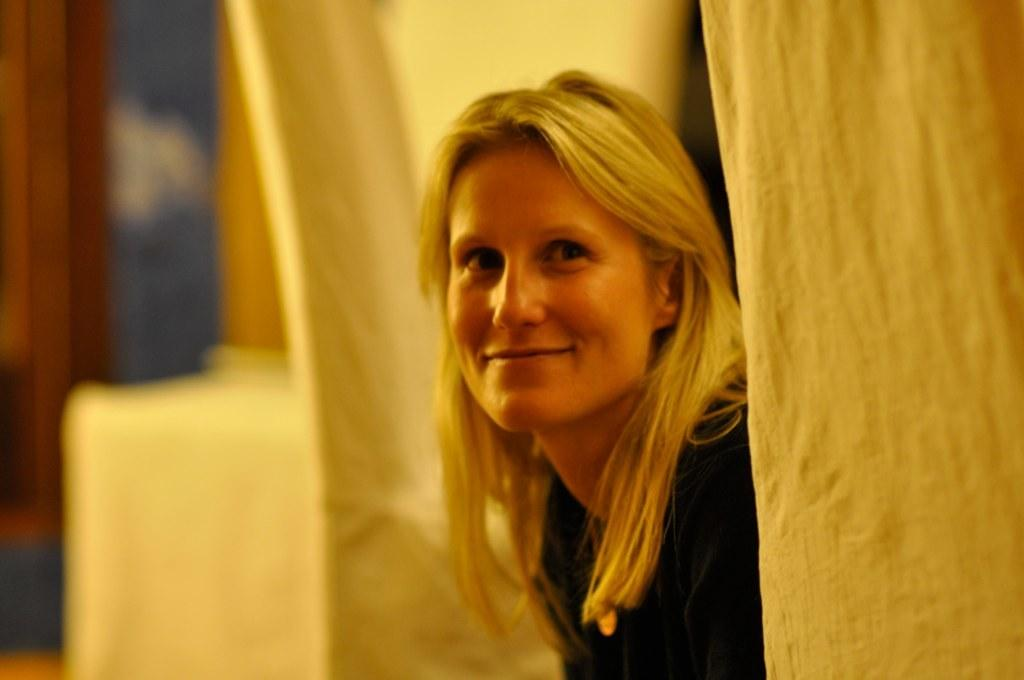Who is in the image? There is a person in the image. What is the person wearing? The person is wearing a black dress. What expression does the person have? The person is smiling. What can be seen next to the person? There is cloth visible next to the person. How would you describe the background of the image? The background of the image is blurred. What type of sweater is the person wearing in the image? The person is not wearing a sweater in the image; they are wearing a black dress. 